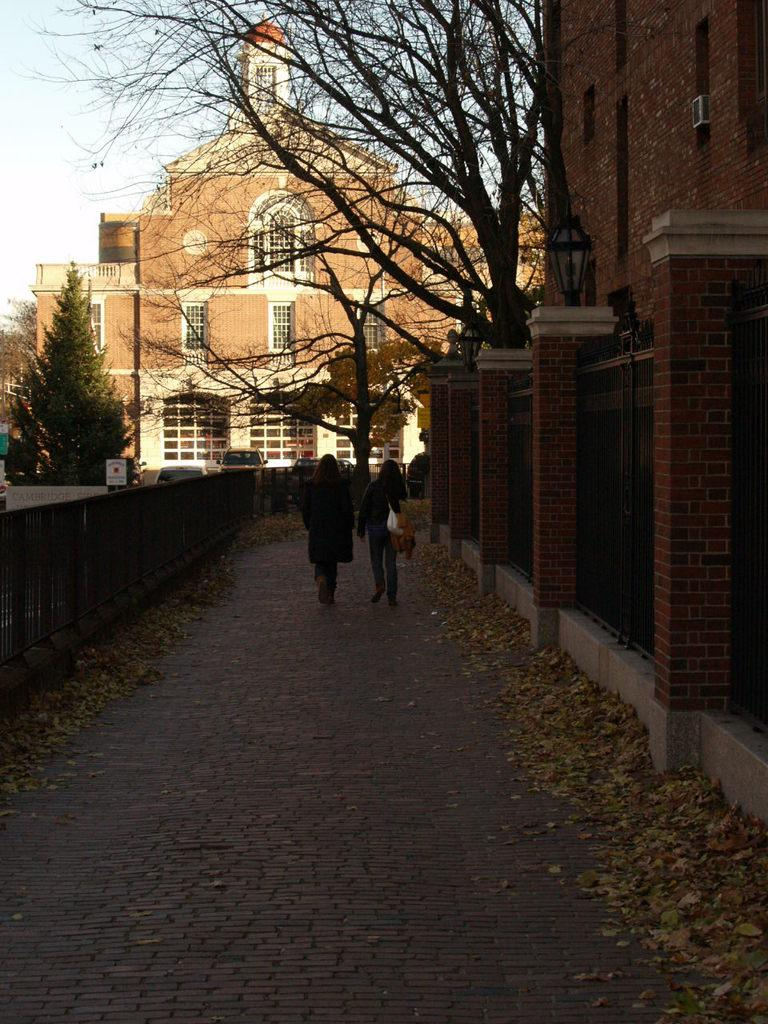What are the two persons in the image doing? The two persons in the image are walking. What structures can be seen in the image? There are buildings in the image. What type of vegetation is present in the image? There are trees in the image. What is visible at the top of the image? The sky is visible at the top of the image. What type of notebook is being used by the trees in the image? There are no notebooks present in the image, as the trees are not human and cannot use notebooks. 